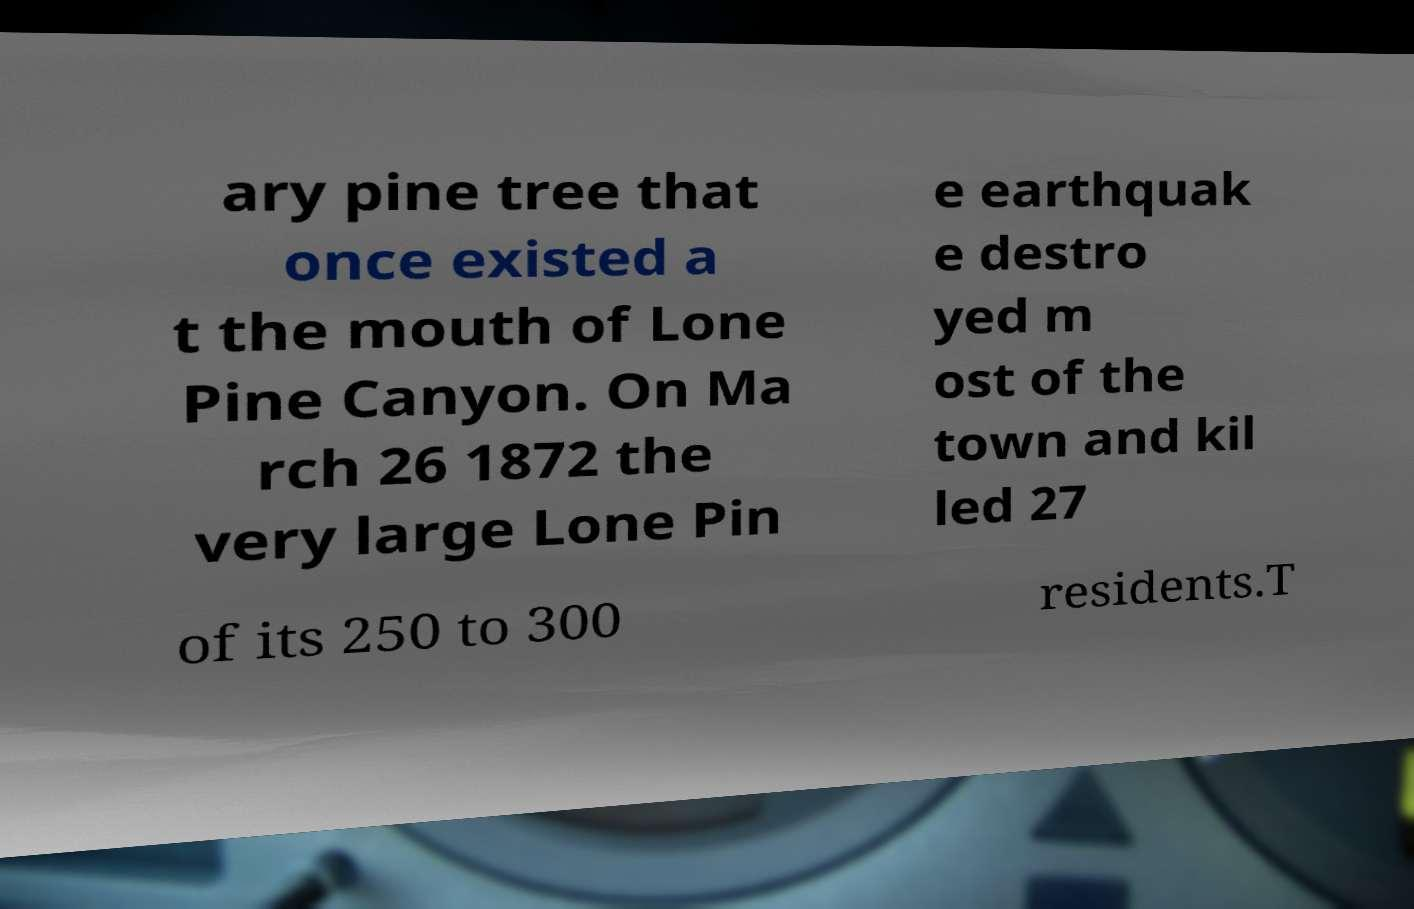I need the written content from this picture converted into text. Can you do that? ary pine tree that once existed a t the mouth of Lone Pine Canyon. On Ma rch 26 1872 the very large Lone Pin e earthquak e destro yed m ost of the town and kil led 27 of its 250 to 300 residents.T 